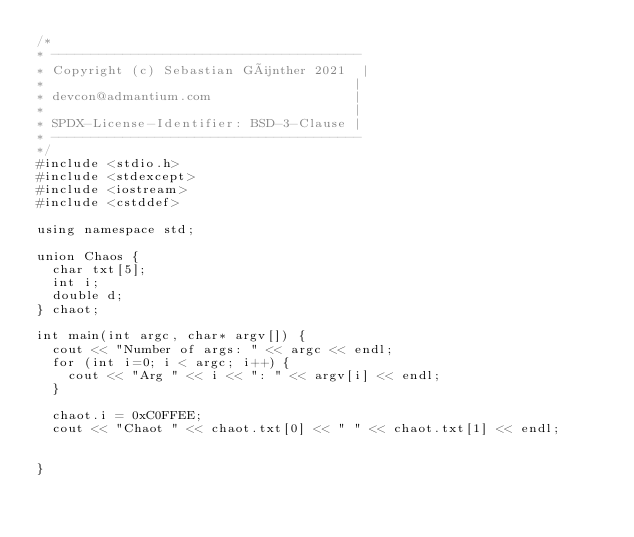Convert code to text. <code><loc_0><loc_0><loc_500><loc_500><_C++_>/* 
* ---------------------------------------
* Copyright (c) Sebastian Günther 2021  |
*                                       |    
* devcon@admantium.com                  |    
*                                       | 
* SPDX-License-Identifier: BSD-3-Clause | 
* ---------------------------------------
*/
#include <stdio.h>
#include <stdexcept>
#include <iostream>
#include <cstddef>

using namespace std;

union Chaos {
  char txt[5];
  int i;
  double d;
} chaot;

int main(int argc, char* argv[]) {
  cout << "Number of args: " << argc << endl;
  for (int i=0; i < argc; i++) {
    cout << "Arg " << i << ": " << argv[i] << endl;
  }
  
  chaot.i = 0xC0FFEE;
  cout << "Chaot " << chaot.txt[0] << " " << chaot.txt[1] << endl;


}</code> 